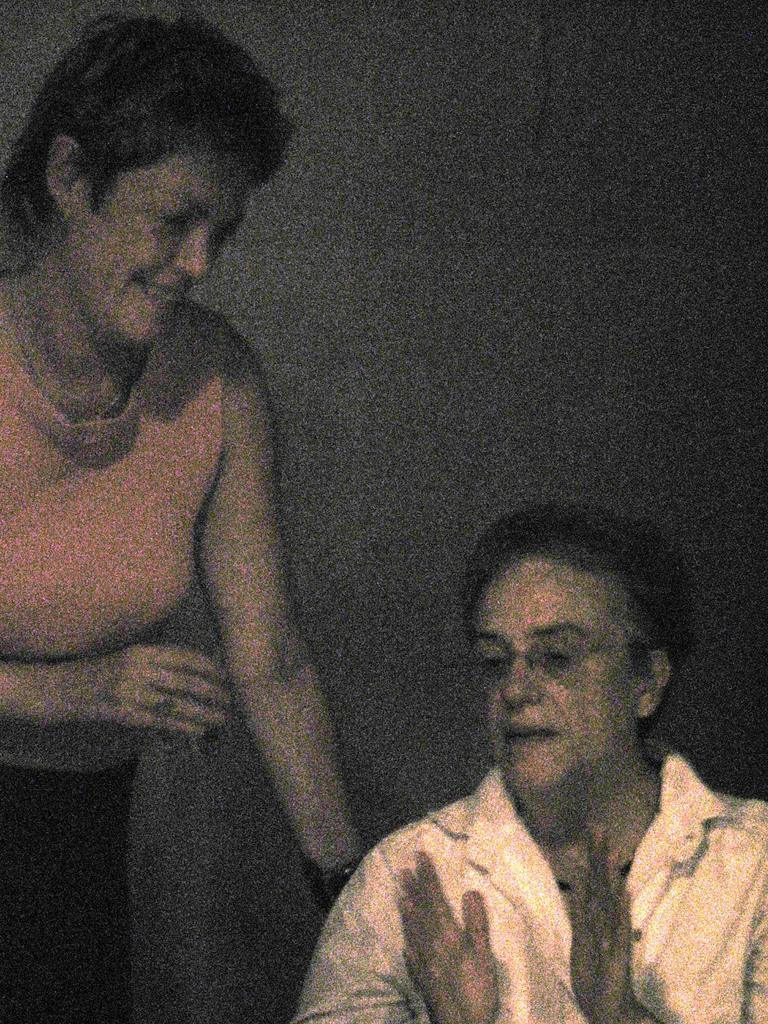How many people are in the image? There are two women in the center of the image. What can be seen in the background of the image? There is a wall in the background of the image. What type of wine is being served in the image? There is no wine present in the image; it only features two women and a wall in the background. 